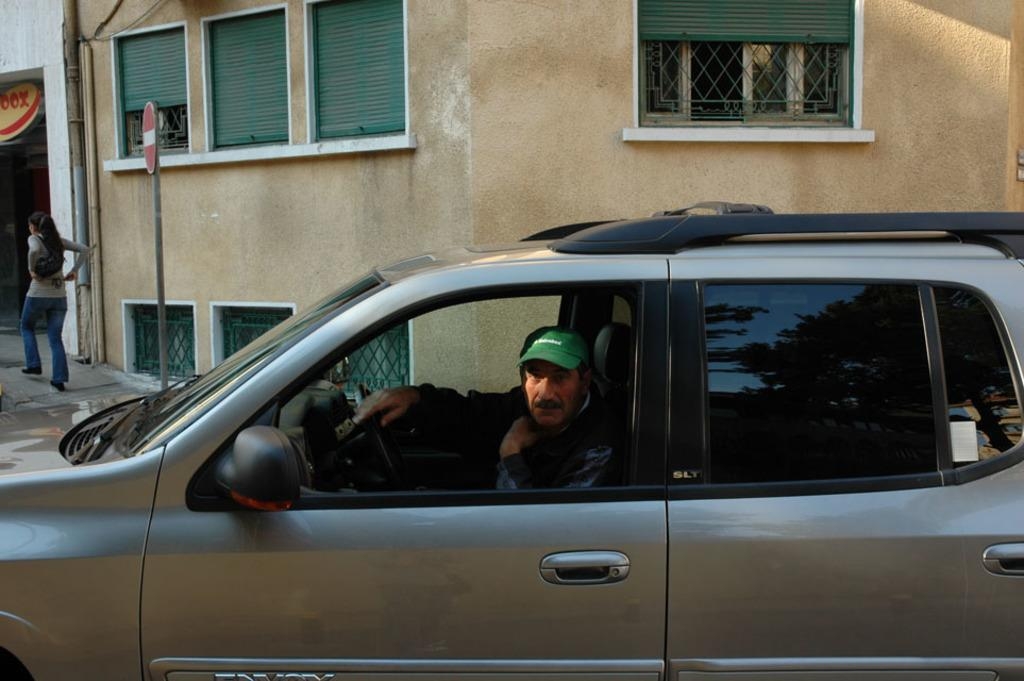What is the man in the image doing? The man is sitting in a car in the image. Can you describe the man's clothing in the image? The man is wearing a green cap in the image. What can be seen in the background of the image? There is a building visible in the image. What is the woman in the image doing? The woman is standing on a footpath in the image. What type of music can be heard coming from the trains in the image? There are no trains present in the image, so it's not possible to determine what, if any, music might be heard. 